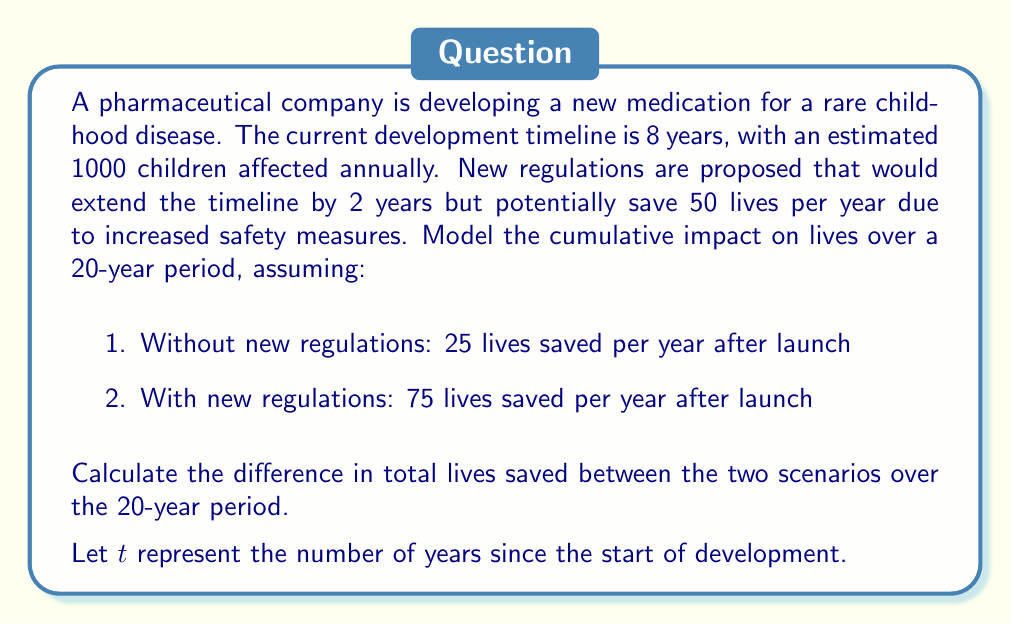Can you answer this question? Let's approach this problem step-by-step:

1) First, let's define our functions for lives saved in each scenario:

   Without new regulations:
   $$f(t) = \begin{cases} 
   0 & \text{if } t < 8 \\
   25(t-8) & \text{if } t \geq 8
   \end{cases}$$

   With new regulations:
   $$g(t) = \begin{cases}
   0 & \text{if } t < 10 \\
   75(t-10) & \text{if } t \geq 10
   \end{cases}$$

2) Now, we need to calculate the total lives saved over 20 years for each scenario:

   Without new regulations:
   $$\int_0^{20} f(t) dt = \int_0^8 0 dt + \int_8^{20} 25(t-8) dt$$
   $$= 0 + 25[\frac{1}{2}t^2 - 8t]_8^{20}$$
   $$= 25[\frac{1}{2}(400 - 64) - 8(20 - 8)]$$
   $$= 25[168 - 96] = 25(72) = 1800$$

   With new regulations:
   $$\int_0^{20} g(t) dt = \int_0^{10} 0 dt + \int_{10}^{20} 75(t-10) dt$$
   $$= 0 + 75[\frac{1}{2}t^2 - 10t]_{10}^{20}$$
   $$= 75[\frac{1}{2}(400 - 100) - 10(20 - 10)]$$
   $$= 75[150 - 100] = 75(50) = 3750$$

3) The difference in total lives saved is:
   $$3750 - 1800 = 1950$$
Answer: The difference in total lives saved over the 20-year period is 1950 more lives saved with the new regulations. 